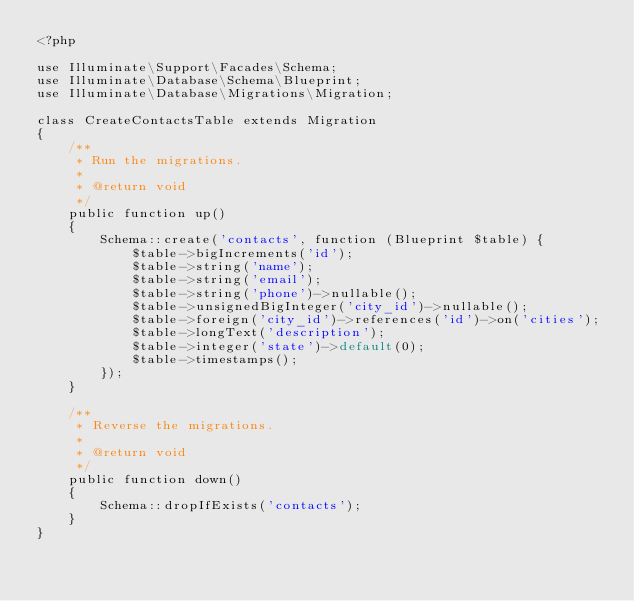Convert code to text. <code><loc_0><loc_0><loc_500><loc_500><_PHP_><?php

use Illuminate\Support\Facades\Schema;
use Illuminate\Database\Schema\Blueprint;
use Illuminate\Database\Migrations\Migration;

class CreateContactsTable extends Migration
{
    /**
     * Run the migrations.
     *
     * @return void
     */
    public function up()
    {
        Schema::create('contacts', function (Blueprint $table) {
            $table->bigIncrements('id');
            $table->string('name');
            $table->string('email');
            $table->string('phone')->nullable();
            $table->unsignedBigInteger('city_id')->nullable();
            $table->foreign('city_id')->references('id')->on('cities');
            $table->longText('description');
            $table->integer('state')->default(0);
            $table->timestamps();
        });
    }

    /**
     * Reverse the migrations.
     *
     * @return void
     */
    public function down()
    {
        Schema::dropIfExists('contacts');
    }
}
</code> 